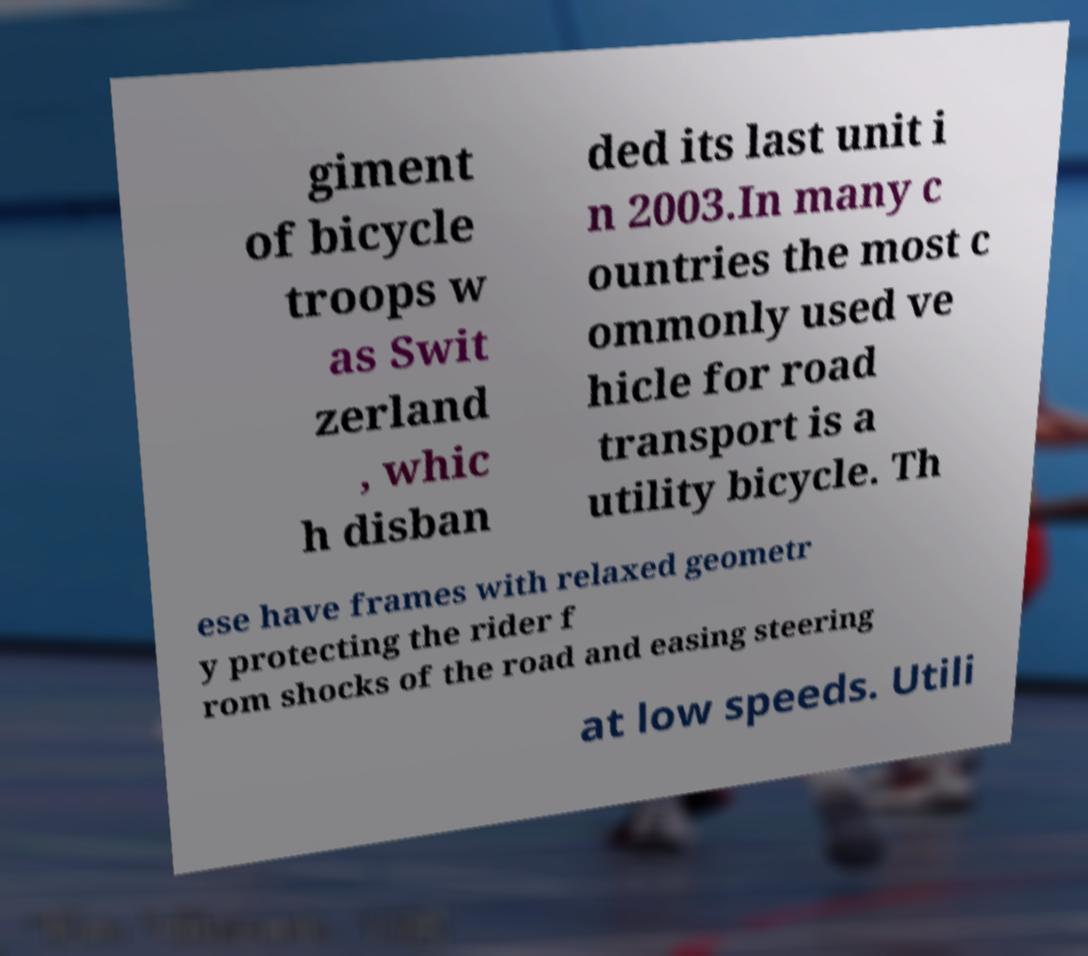Could you extract and type out the text from this image? giment of bicycle troops w as Swit zerland , whic h disban ded its last unit i n 2003.In many c ountries the most c ommonly used ve hicle for road transport is a utility bicycle. Th ese have frames with relaxed geometr y protecting the rider f rom shocks of the road and easing steering at low speeds. Utili 